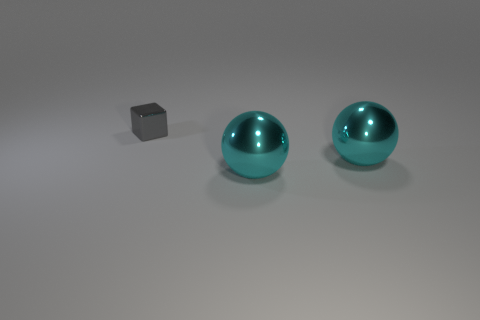Add 3 small rubber spheres. How many objects exist? 6 Subtract all cubes. How many objects are left? 2 Subtract all cyan things. Subtract all small objects. How many objects are left? 0 Add 1 tiny gray shiny things. How many tiny gray shiny things are left? 2 Add 3 metallic balls. How many metallic balls exist? 5 Subtract 2 cyan spheres. How many objects are left? 1 